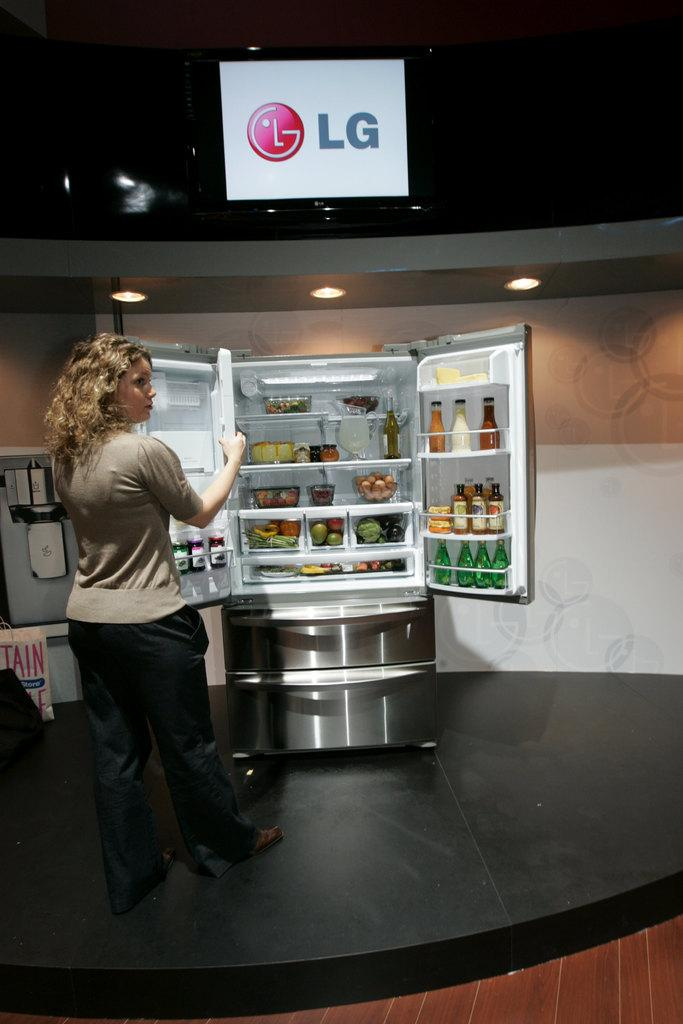<image>
Offer a succinct explanation of the picture presented. A woman demonstrating how to use the LG refrigerator. 